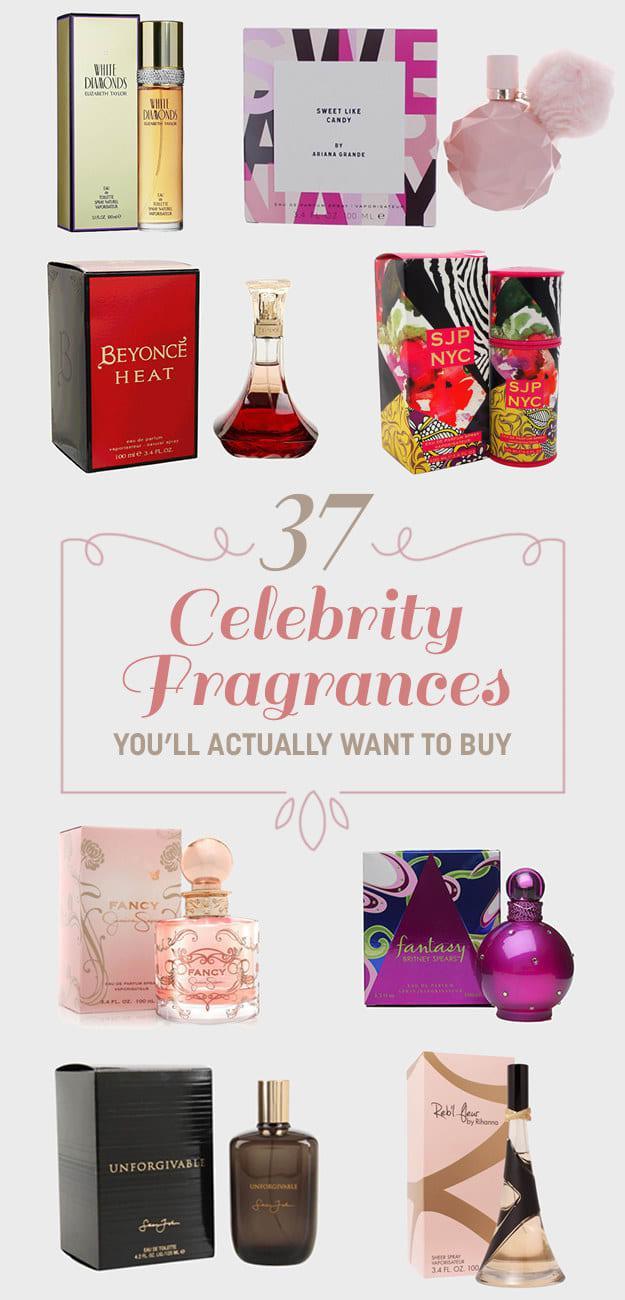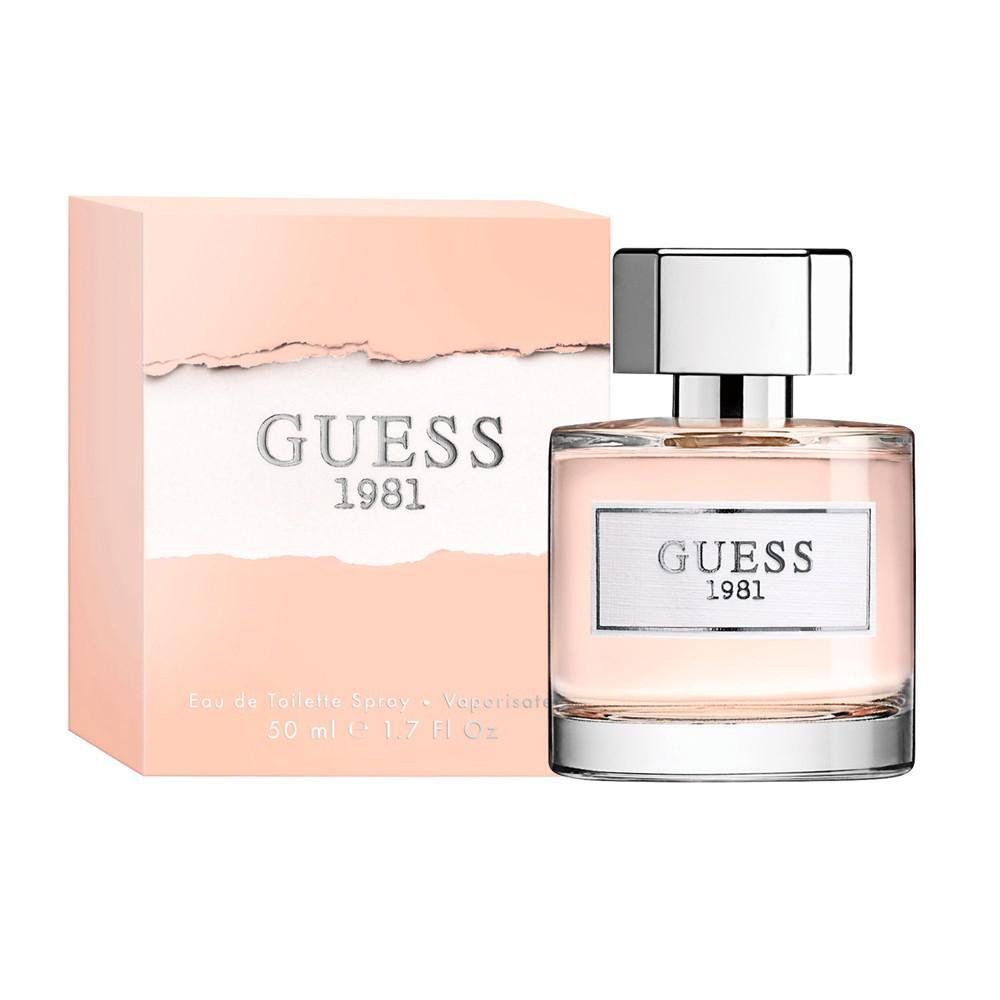The first image is the image on the left, the second image is the image on the right. Given the left and right images, does the statement "One image shows exactly one fragrance bottle next to its box but not overlapping it." hold true? Answer yes or no. No. The first image is the image on the left, the second image is the image on the right. Evaluate the accuracy of this statement regarding the images: "There is a single glass bottle of perfume next to it's box with a clear cap". Is it true? Answer yes or no. No. 